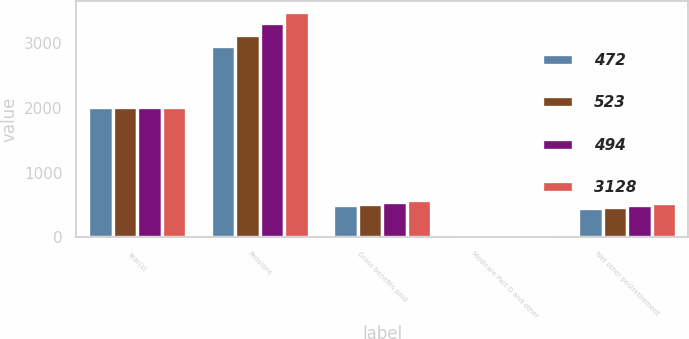<chart> <loc_0><loc_0><loc_500><loc_500><stacked_bar_chart><ecel><fcel>Year(s)<fcel>Pensions<fcel>Gross benefits paid<fcel>Medicare Part D and other<fcel>Net other postretirement<nl><fcel>472<fcel>2013<fcel>2968<fcel>496<fcel>46<fcel>450<nl><fcel>523<fcel>2014<fcel>3132<fcel>519<fcel>47<fcel>472<nl><fcel>494<fcel>2015<fcel>3309<fcel>543<fcel>49<fcel>494<nl><fcel>3128<fcel>2016<fcel>3488<fcel>572<fcel>49<fcel>523<nl></chart> 